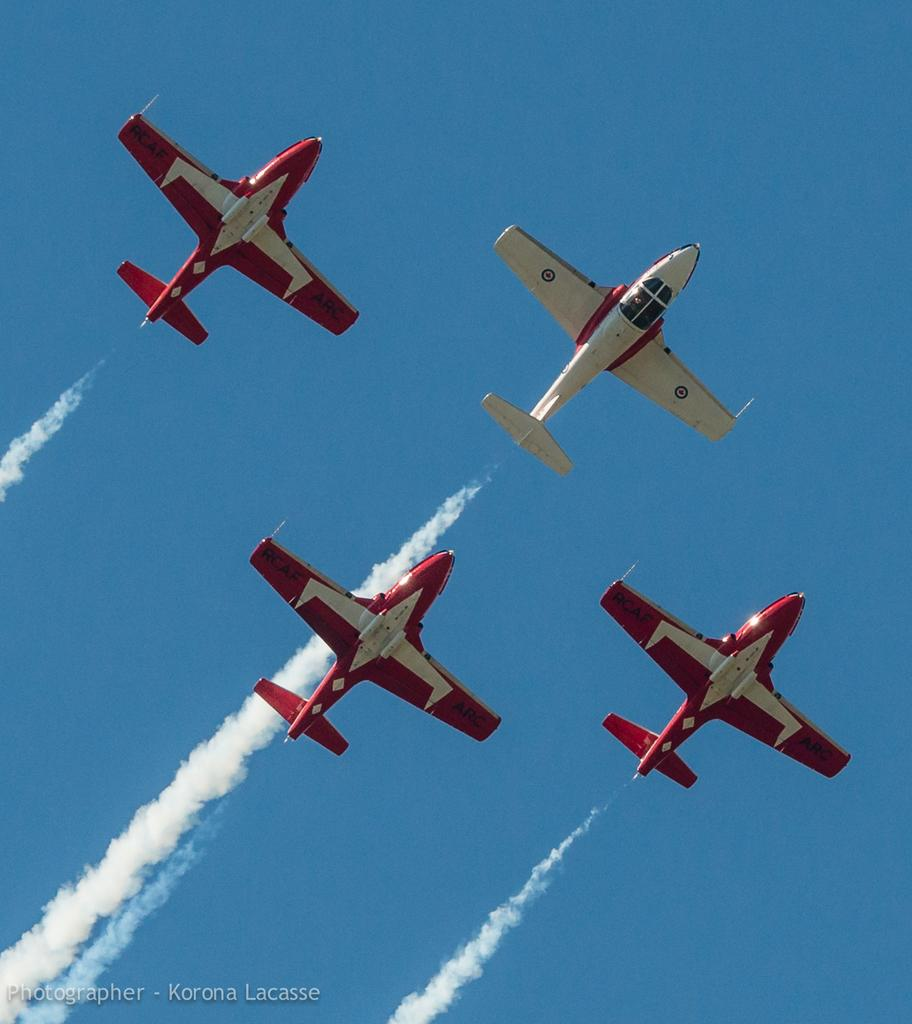What is the main subject of the image? The main subject of the image is airplanes. What are the airplanes doing in the image? The airplanes are exhaling smoke in the image. Is there any text present in the image? Yes, there is some text in the bottom left of the image. What can be seen in the background of the image? The sky is visible in the background of the image. Can you see any ghosts in the image? No, there are no ghosts present in the image. What type of stamp is visible on the airplane in the image? There is no stamp visible on the airplane in the image. 